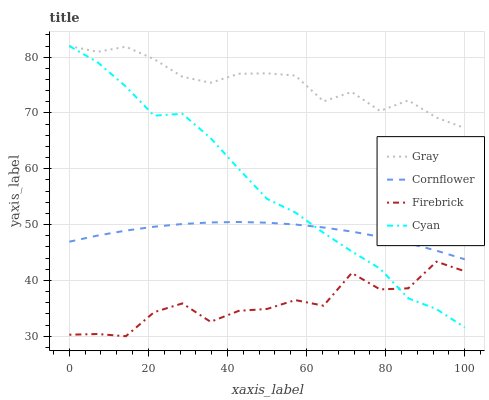Does Cyan have the minimum area under the curve?
Answer yes or no. No. Does Cyan have the maximum area under the curve?
Answer yes or no. No. Is Cyan the smoothest?
Answer yes or no. No. Is Cyan the roughest?
Answer yes or no. No. Does Cyan have the lowest value?
Answer yes or no. No. Does Firebrick have the highest value?
Answer yes or no. No. Is Firebrick less than Gray?
Answer yes or no. Yes. Is Gray greater than Cornflower?
Answer yes or no. Yes. Does Firebrick intersect Gray?
Answer yes or no. No. 